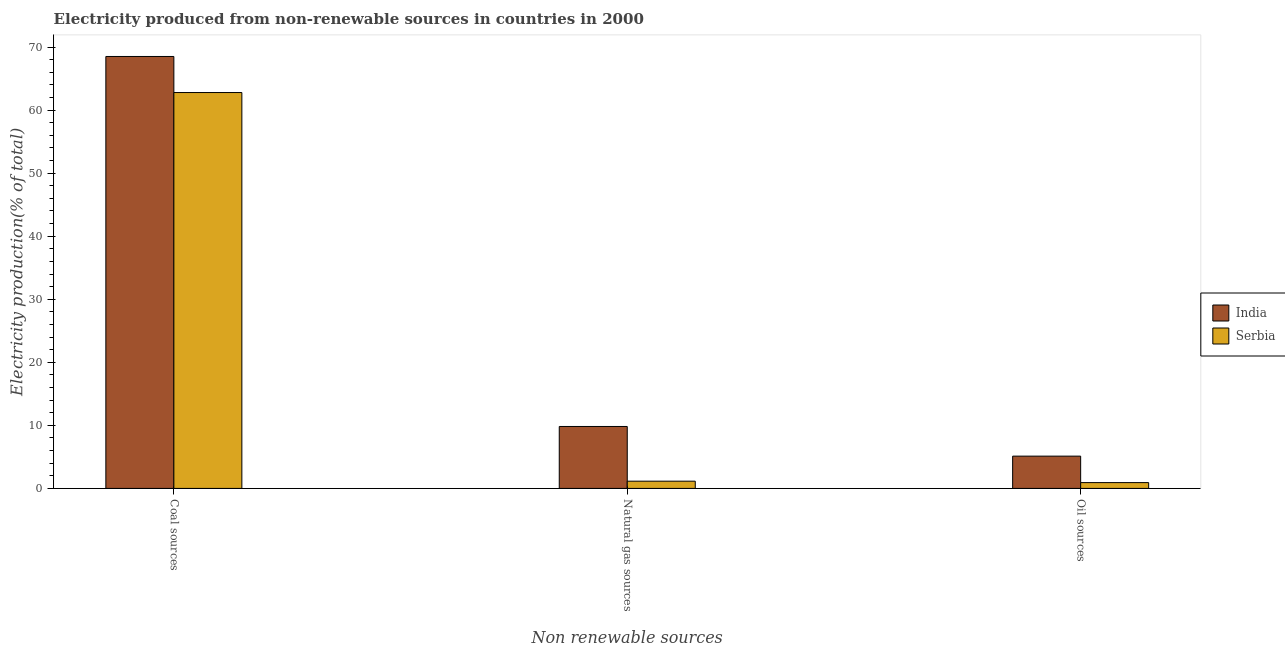Are the number of bars per tick equal to the number of legend labels?
Ensure brevity in your answer.  Yes. What is the label of the 1st group of bars from the left?
Provide a short and direct response. Coal sources. What is the percentage of electricity produced by natural gas in India?
Provide a short and direct response. 9.82. Across all countries, what is the maximum percentage of electricity produced by natural gas?
Offer a very short reply. 9.82. Across all countries, what is the minimum percentage of electricity produced by natural gas?
Provide a succinct answer. 1.15. In which country was the percentage of electricity produced by oil sources minimum?
Keep it short and to the point. Serbia. What is the total percentage of electricity produced by oil sources in the graph?
Provide a succinct answer. 6.04. What is the difference between the percentage of electricity produced by coal in India and that in Serbia?
Your response must be concise. 5.72. What is the difference between the percentage of electricity produced by coal in India and the percentage of electricity produced by natural gas in Serbia?
Make the answer very short. 67.35. What is the average percentage of electricity produced by oil sources per country?
Keep it short and to the point. 3.02. What is the difference between the percentage of electricity produced by oil sources and percentage of electricity produced by natural gas in India?
Keep it short and to the point. -4.7. In how many countries, is the percentage of electricity produced by natural gas greater than 48 %?
Your response must be concise. 0. What is the ratio of the percentage of electricity produced by natural gas in India to that in Serbia?
Provide a short and direct response. 8.56. Is the percentage of electricity produced by natural gas in India less than that in Serbia?
Make the answer very short. No. What is the difference between the highest and the second highest percentage of electricity produced by coal?
Provide a short and direct response. 5.72. What is the difference between the highest and the lowest percentage of electricity produced by oil sources?
Give a very brief answer. 4.2. In how many countries, is the percentage of electricity produced by natural gas greater than the average percentage of electricity produced by natural gas taken over all countries?
Keep it short and to the point. 1. Are all the bars in the graph horizontal?
Make the answer very short. No. What is the difference between two consecutive major ticks on the Y-axis?
Your answer should be very brief. 10. Are the values on the major ticks of Y-axis written in scientific E-notation?
Your response must be concise. No. Does the graph contain grids?
Offer a very short reply. No. Where does the legend appear in the graph?
Your response must be concise. Center right. How are the legend labels stacked?
Offer a very short reply. Vertical. What is the title of the graph?
Your answer should be compact. Electricity produced from non-renewable sources in countries in 2000. Does "Turkey" appear as one of the legend labels in the graph?
Ensure brevity in your answer.  No. What is the label or title of the X-axis?
Your answer should be compact. Non renewable sources. What is the Electricity production(% of total) of India in Coal sources?
Make the answer very short. 68.5. What is the Electricity production(% of total) in Serbia in Coal sources?
Keep it short and to the point. 62.78. What is the Electricity production(% of total) in India in Natural gas sources?
Your response must be concise. 9.82. What is the Electricity production(% of total) of Serbia in Natural gas sources?
Provide a short and direct response. 1.15. What is the Electricity production(% of total) of India in Oil sources?
Give a very brief answer. 5.12. What is the Electricity production(% of total) in Serbia in Oil sources?
Make the answer very short. 0.92. Across all Non renewable sources, what is the maximum Electricity production(% of total) of India?
Provide a succinct answer. 68.5. Across all Non renewable sources, what is the maximum Electricity production(% of total) in Serbia?
Ensure brevity in your answer.  62.78. Across all Non renewable sources, what is the minimum Electricity production(% of total) in India?
Your response must be concise. 5.12. Across all Non renewable sources, what is the minimum Electricity production(% of total) of Serbia?
Provide a short and direct response. 0.92. What is the total Electricity production(% of total) of India in the graph?
Your response must be concise. 83.44. What is the total Electricity production(% of total) of Serbia in the graph?
Your response must be concise. 64.85. What is the difference between the Electricity production(% of total) in India in Coal sources and that in Natural gas sources?
Keep it short and to the point. 58.68. What is the difference between the Electricity production(% of total) in Serbia in Coal sources and that in Natural gas sources?
Give a very brief answer. 61.63. What is the difference between the Electricity production(% of total) of India in Coal sources and that in Oil sources?
Your answer should be very brief. 63.38. What is the difference between the Electricity production(% of total) in Serbia in Coal sources and that in Oil sources?
Ensure brevity in your answer.  61.86. What is the difference between the Electricity production(% of total) in India in Natural gas sources and that in Oil sources?
Provide a short and direct response. 4.7. What is the difference between the Electricity production(% of total) in Serbia in Natural gas sources and that in Oil sources?
Make the answer very short. 0.23. What is the difference between the Electricity production(% of total) in India in Coal sources and the Electricity production(% of total) in Serbia in Natural gas sources?
Make the answer very short. 67.35. What is the difference between the Electricity production(% of total) of India in Coal sources and the Electricity production(% of total) of Serbia in Oil sources?
Offer a terse response. 67.58. What is the difference between the Electricity production(% of total) of India in Natural gas sources and the Electricity production(% of total) of Serbia in Oil sources?
Offer a terse response. 8.9. What is the average Electricity production(% of total) in India per Non renewable sources?
Give a very brief answer. 27.81. What is the average Electricity production(% of total) in Serbia per Non renewable sources?
Your answer should be compact. 21.62. What is the difference between the Electricity production(% of total) of India and Electricity production(% of total) of Serbia in Coal sources?
Offer a terse response. 5.72. What is the difference between the Electricity production(% of total) in India and Electricity production(% of total) in Serbia in Natural gas sources?
Your answer should be compact. 8.68. What is the difference between the Electricity production(% of total) of India and Electricity production(% of total) of Serbia in Oil sources?
Offer a very short reply. 4.2. What is the ratio of the Electricity production(% of total) in India in Coal sources to that in Natural gas sources?
Give a very brief answer. 6.97. What is the ratio of the Electricity production(% of total) in Serbia in Coal sources to that in Natural gas sources?
Provide a succinct answer. 54.68. What is the ratio of the Electricity production(% of total) in India in Coal sources to that in Oil sources?
Make the answer very short. 13.38. What is the ratio of the Electricity production(% of total) in Serbia in Coal sources to that in Oil sources?
Your answer should be very brief. 68.04. What is the ratio of the Electricity production(% of total) in India in Natural gas sources to that in Oil sources?
Ensure brevity in your answer.  1.92. What is the ratio of the Electricity production(% of total) of Serbia in Natural gas sources to that in Oil sources?
Your response must be concise. 1.24. What is the difference between the highest and the second highest Electricity production(% of total) in India?
Provide a short and direct response. 58.68. What is the difference between the highest and the second highest Electricity production(% of total) of Serbia?
Your answer should be compact. 61.63. What is the difference between the highest and the lowest Electricity production(% of total) of India?
Your answer should be compact. 63.38. What is the difference between the highest and the lowest Electricity production(% of total) in Serbia?
Your response must be concise. 61.86. 